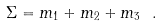Convert formula to latex. <formula><loc_0><loc_0><loc_500><loc_500>\Sigma = m _ { 1 } + m _ { 2 } + m _ { 3 } \ .</formula> 